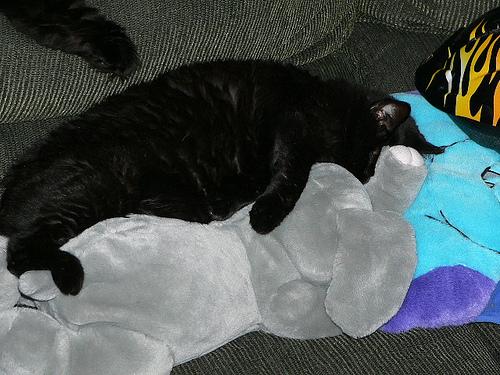Is the elephant alive?
Answer briefly. No. How many cats are in the image?
Give a very brief answer. 1. Does this cat look comfortable?
Answer briefly. Yes. 